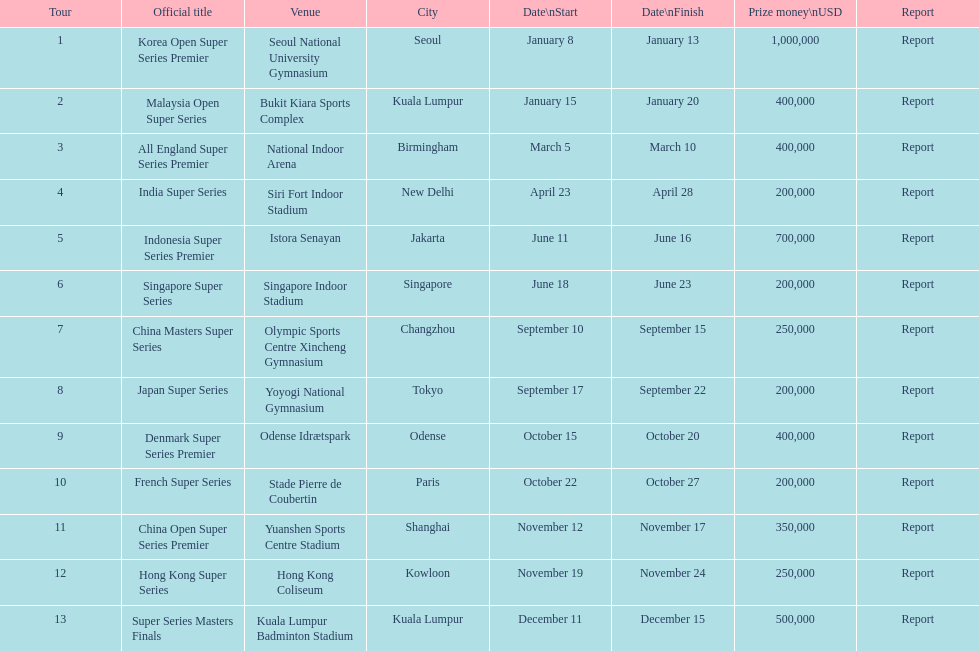How many happen in the final six months of the year? 7. 